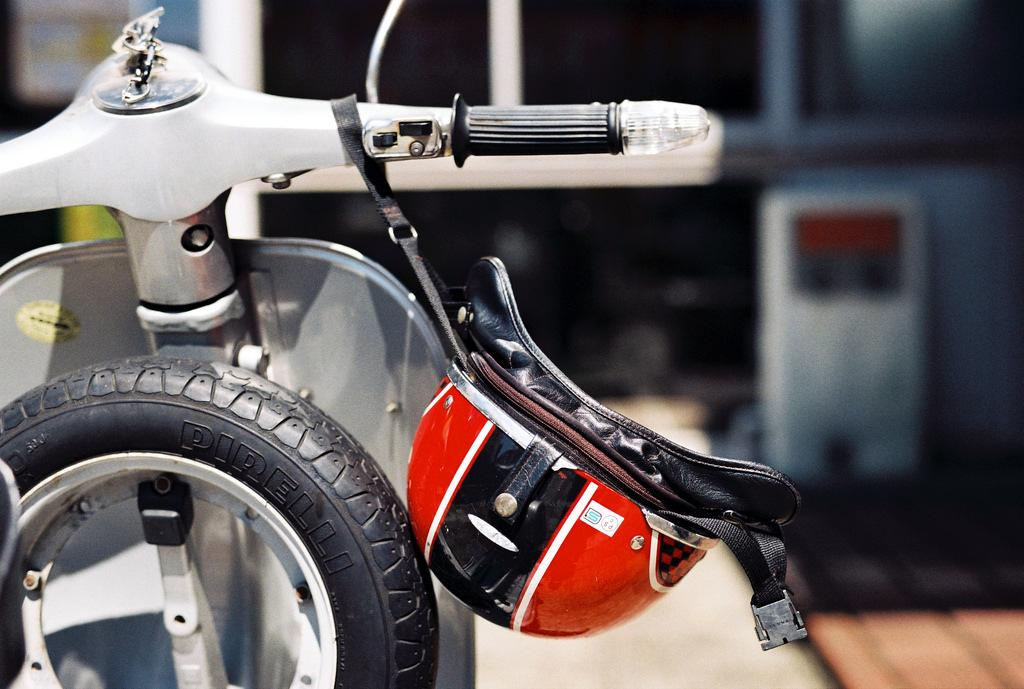What vehicle is present in the image? There is a scooter in the image. What part of the scooter is visible in the image? There is a tyre in the image. What safety gear is shown in the image? There is a helmet in the image. Can you describe the background of the image? The background of the image is blurred. What type of ice can be seen on the moon in the image? There is no ice or moon present in the image; it features a scooter, tyre, helmet, and a blurred background. 